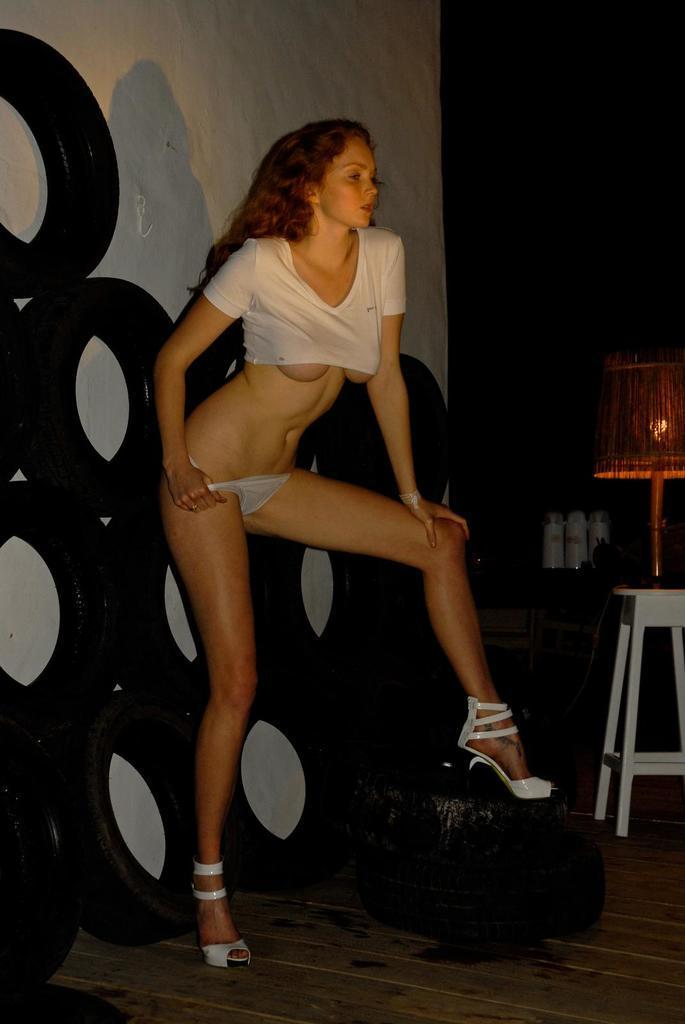Could you give a brief overview of what you see in this image? In this image there is a woman, she is standing and there are few tires behind the woman and there is a lamp and a stool on the right side. 